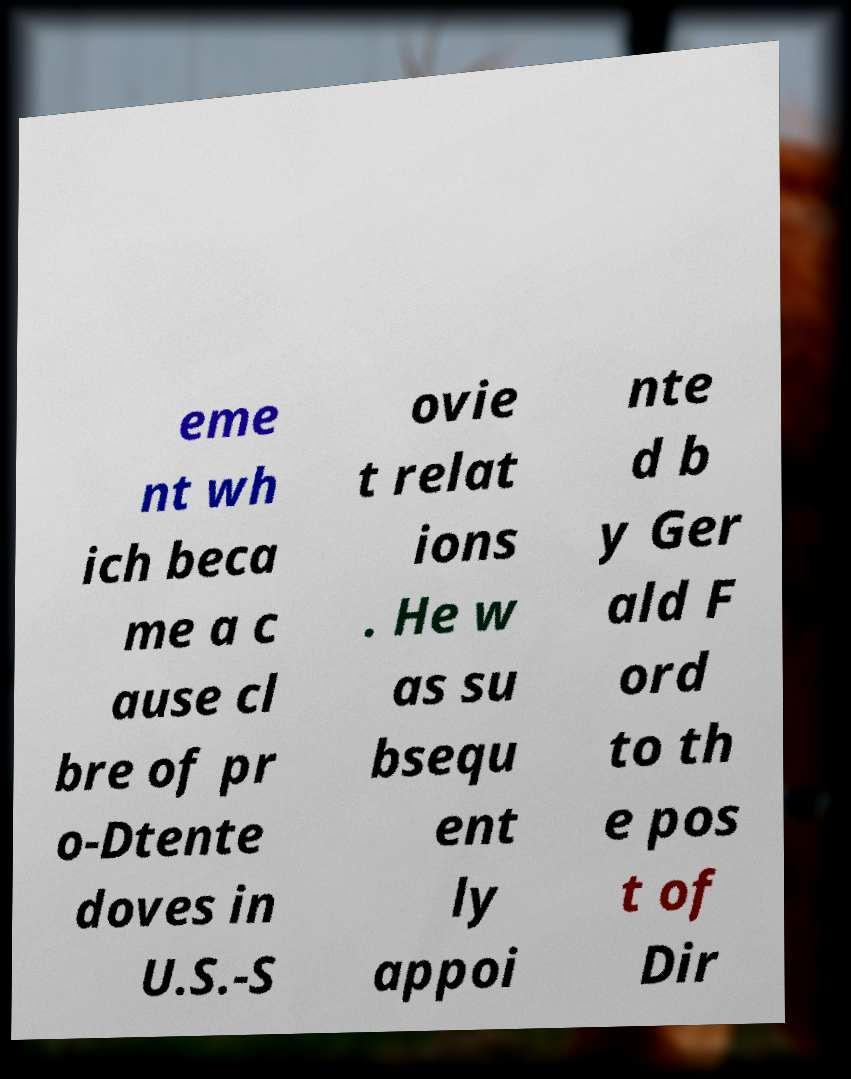Could you extract and type out the text from this image? eme nt wh ich beca me a c ause cl bre of pr o-Dtente doves in U.S.-S ovie t relat ions . He w as su bsequ ent ly appoi nte d b y Ger ald F ord to th e pos t of Dir 